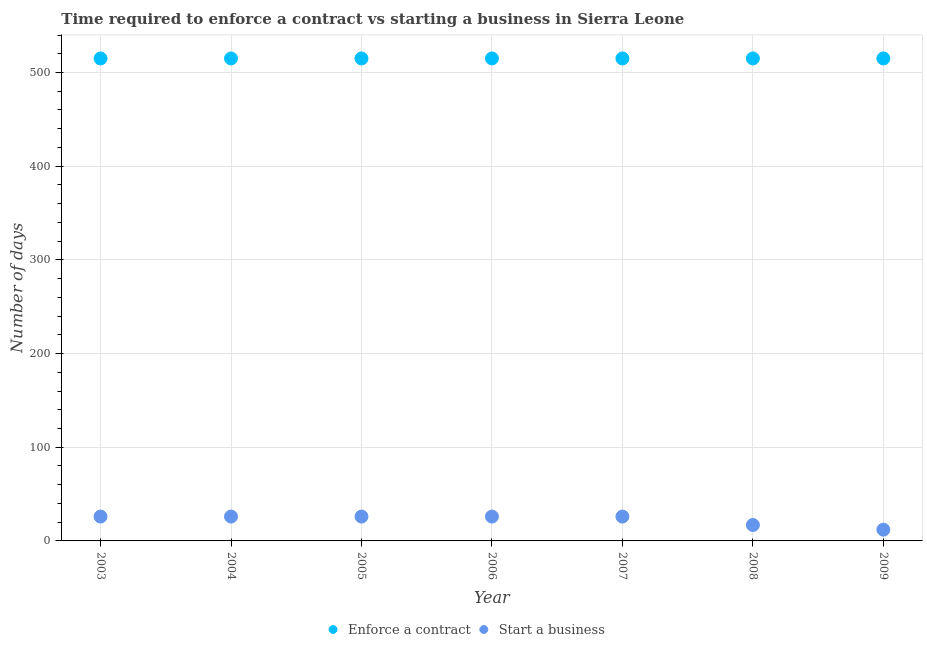How many different coloured dotlines are there?
Your answer should be very brief. 2. What is the number of days to start a business in 2005?
Your answer should be very brief. 26. Across all years, what is the maximum number of days to start a business?
Keep it short and to the point. 26. Across all years, what is the minimum number of days to start a business?
Give a very brief answer. 12. What is the total number of days to start a business in the graph?
Your answer should be very brief. 159. What is the difference between the number of days to start a business in 2008 and that in 2009?
Your response must be concise. 5. What is the difference between the number of days to enforece a contract in 2007 and the number of days to start a business in 2004?
Your answer should be compact. 489. What is the average number of days to enforece a contract per year?
Your response must be concise. 515. In the year 2008, what is the difference between the number of days to enforece a contract and number of days to start a business?
Make the answer very short. 498. What is the ratio of the number of days to enforece a contract in 2007 to that in 2009?
Make the answer very short. 1. Is the difference between the number of days to enforece a contract in 2004 and 2007 greater than the difference between the number of days to start a business in 2004 and 2007?
Keep it short and to the point. No. What is the difference between the highest and the lowest number of days to start a business?
Your response must be concise. 14. Is the sum of the number of days to start a business in 2003 and 2007 greater than the maximum number of days to enforece a contract across all years?
Your answer should be compact. No. Is the number of days to enforece a contract strictly greater than the number of days to start a business over the years?
Your answer should be very brief. Yes. Is the number of days to enforece a contract strictly less than the number of days to start a business over the years?
Keep it short and to the point. No. How many years are there in the graph?
Give a very brief answer. 7. What is the difference between two consecutive major ticks on the Y-axis?
Keep it short and to the point. 100. Where does the legend appear in the graph?
Provide a short and direct response. Bottom center. How are the legend labels stacked?
Provide a short and direct response. Horizontal. What is the title of the graph?
Your answer should be compact. Time required to enforce a contract vs starting a business in Sierra Leone. What is the label or title of the X-axis?
Ensure brevity in your answer.  Year. What is the label or title of the Y-axis?
Your answer should be very brief. Number of days. What is the Number of days in Enforce a contract in 2003?
Your answer should be very brief. 515. What is the Number of days of Enforce a contract in 2004?
Keep it short and to the point. 515. What is the Number of days in Enforce a contract in 2005?
Offer a terse response. 515. What is the Number of days of Enforce a contract in 2006?
Keep it short and to the point. 515. What is the Number of days of Start a business in 2006?
Your answer should be very brief. 26. What is the Number of days of Enforce a contract in 2007?
Offer a very short reply. 515. What is the Number of days of Enforce a contract in 2008?
Offer a terse response. 515. What is the Number of days of Start a business in 2008?
Your answer should be very brief. 17. What is the Number of days of Enforce a contract in 2009?
Keep it short and to the point. 515. What is the Number of days in Start a business in 2009?
Your answer should be compact. 12. Across all years, what is the maximum Number of days in Enforce a contract?
Offer a very short reply. 515. Across all years, what is the minimum Number of days of Enforce a contract?
Keep it short and to the point. 515. Across all years, what is the minimum Number of days of Start a business?
Your response must be concise. 12. What is the total Number of days in Enforce a contract in the graph?
Give a very brief answer. 3605. What is the total Number of days in Start a business in the graph?
Provide a short and direct response. 159. What is the difference between the Number of days in Enforce a contract in 2003 and that in 2004?
Ensure brevity in your answer.  0. What is the difference between the Number of days of Start a business in 2003 and that in 2004?
Your response must be concise. 0. What is the difference between the Number of days of Enforce a contract in 2003 and that in 2005?
Your answer should be compact. 0. What is the difference between the Number of days of Start a business in 2003 and that in 2005?
Ensure brevity in your answer.  0. What is the difference between the Number of days of Enforce a contract in 2003 and that in 2007?
Your answer should be compact. 0. What is the difference between the Number of days of Start a business in 2003 and that in 2007?
Your response must be concise. 0. What is the difference between the Number of days in Enforce a contract in 2003 and that in 2008?
Give a very brief answer. 0. What is the difference between the Number of days of Start a business in 2003 and that in 2008?
Offer a terse response. 9. What is the difference between the Number of days in Start a business in 2004 and that in 2005?
Your answer should be very brief. 0. What is the difference between the Number of days in Start a business in 2004 and that in 2007?
Give a very brief answer. 0. What is the difference between the Number of days in Enforce a contract in 2004 and that in 2008?
Give a very brief answer. 0. What is the difference between the Number of days in Enforce a contract in 2005 and that in 2006?
Provide a succinct answer. 0. What is the difference between the Number of days of Start a business in 2005 and that in 2007?
Make the answer very short. 0. What is the difference between the Number of days of Enforce a contract in 2005 and that in 2008?
Keep it short and to the point. 0. What is the difference between the Number of days of Start a business in 2005 and that in 2008?
Your answer should be very brief. 9. What is the difference between the Number of days in Start a business in 2005 and that in 2009?
Make the answer very short. 14. What is the difference between the Number of days in Enforce a contract in 2006 and that in 2007?
Your response must be concise. 0. What is the difference between the Number of days of Start a business in 2006 and that in 2008?
Ensure brevity in your answer.  9. What is the difference between the Number of days in Start a business in 2006 and that in 2009?
Keep it short and to the point. 14. What is the difference between the Number of days in Enforce a contract in 2007 and that in 2008?
Offer a very short reply. 0. What is the difference between the Number of days in Start a business in 2007 and that in 2008?
Your response must be concise. 9. What is the difference between the Number of days in Enforce a contract in 2007 and that in 2009?
Ensure brevity in your answer.  0. What is the difference between the Number of days of Start a business in 2007 and that in 2009?
Offer a terse response. 14. What is the difference between the Number of days of Enforce a contract in 2008 and that in 2009?
Your response must be concise. 0. What is the difference between the Number of days in Enforce a contract in 2003 and the Number of days in Start a business in 2004?
Offer a terse response. 489. What is the difference between the Number of days in Enforce a contract in 2003 and the Number of days in Start a business in 2005?
Make the answer very short. 489. What is the difference between the Number of days in Enforce a contract in 2003 and the Number of days in Start a business in 2006?
Ensure brevity in your answer.  489. What is the difference between the Number of days of Enforce a contract in 2003 and the Number of days of Start a business in 2007?
Provide a succinct answer. 489. What is the difference between the Number of days in Enforce a contract in 2003 and the Number of days in Start a business in 2008?
Your response must be concise. 498. What is the difference between the Number of days in Enforce a contract in 2003 and the Number of days in Start a business in 2009?
Offer a terse response. 503. What is the difference between the Number of days of Enforce a contract in 2004 and the Number of days of Start a business in 2005?
Offer a very short reply. 489. What is the difference between the Number of days in Enforce a contract in 2004 and the Number of days in Start a business in 2006?
Your response must be concise. 489. What is the difference between the Number of days of Enforce a contract in 2004 and the Number of days of Start a business in 2007?
Provide a short and direct response. 489. What is the difference between the Number of days in Enforce a contract in 2004 and the Number of days in Start a business in 2008?
Provide a succinct answer. 498. What is the difference between the Number of days in Enforce a contract in 2004 and the Number of days in Start a business in 2009?
Provide a short and direct response. 503. What is the difference between the Number of days in Enforce a contract in 2005 and the Number of days in Start a business in 2006?
Your answer should be compact. 489. What is the difference between the Number of days in Enforce a contract in 2005 and the Number of days in Start a business in 2007?
Provide a short and direct response. 489. What is the difference between the Number of days of Enforce a contract in 2005 and the Number of days of Start a business in 2008?
Provide a succinct answer. 498. What is the difference between the Number of days of Enforce a contract in 2005 and the Number of days of Start a business in 2009?
Give a very brief answer. 503. What is the difference between the Number of days in Enforce a contract in 2006 and the Number of days in Start a business in 2007?
Ensure brevity in your answer.  489. What is the difference between the Number of days in Enforce a contract in 2006 and the Number of days in Start a business in 2008?
Give a very brief answer. 498. What is the difference between the Number of days of Enforce a contract in 2006 and the Number of days of Start a business in 2009?
Your answer should be very brief. 503. What is the difference between the Number of days of Enforce a contract in 2007 and the Number of days of Start a business in 2008?
Provide a succinct answer. 498. What is the difference between the Number of days of Enforce a contract in 2007 and the Number of days of Start a business in 2009?
Give a very brief answer. 503. What is the difference between the Number of days in Enforce a contract in 2008 and the Number of days in Start a business in 2009?
Provide a succinct answer. 503. What is the average Number of days of Enforce a contract per year?
Offer a terse response. 515. What is the average Number of days of Start a business per year?
Your answer should be very brief. 22.71. In the year 2003, what is the difference between the Number of days of Enforce a contract and Number of days of Start a business?
Your answer should be very brief. 489. In the year 2004, what is the difference between the Number of days of Enforce a contract and Number of days of Start a business?
Give a very brief answer. 489. In the year 2005, what is the difference between the Number of days in Enforce a contract and Number of days in Start a business?
Your answer should be compact. 489. In the year 2006, what is the difference between the Number of days in Enforce a contract and Number of days in Start a business?
Keep it short and to the point. 489. In the year 2007, what is the difference between the Number of days in Enforce a contract and Number of days in Start a business?
Ensure brevity in your answer.  489. In the year 2008, what is the difference between the Number of days of Enforce a contract and Number of days of Start a business?
Offer a very short reply. 498. In the year 2009, what is the difference between the Number of days in Enforce a contract and Number of days in Start a business?
Your response must be concise. 503. What is the ratio of the Number of days in Enforce a contract in 2003 to that in 2005?
Provide a succinct answer. 1. What is the ratio of the Number of days of Start a business in 2003 to that in 2005?
Your answer should be very brief. 1. What is the ratio of the Number of days in Enforce a contract in 2003 to that in 2006?
Your response must be concise. 1. What is the ratio of the Number of days of Start a business in 2003 to that in 2006?
Provide a succinct answer. 1. What is the ratio of the Number of days of Enforce a contract in 2003 to that in 2008?
Your answer should be very brief. 1. What is the ratio of the Number of days of Start a business in 2003 to that in 2008?
Your answer should be compact. 1.53. What is the ratio of the Number of days in Enforce a contract in 2003 to that in 2009?
Offer a terse response. 1. What is the ratio of the Number of days in Start a business in 2003 to that in 2009?
Keep it short and to the point. 2.17. What is the ratio of the Number of days of Start a business in 2004 to that in 2005?
Keep it short and to the point. 1. What is the ratio of the Number of days of Start a business in 2004 to that in 2006?
Provide a succinct answer. 1. What is the ratio of the Number of days in Enforce a contract in 2004 to that in 2007?
Your response must be concise. 1. What is the ratio of the Number of days in Start a business in 2004 to that in 2007?
Provide a succinct answer. 1. What is the ratio of the Number of days in Start a business in 2004 to that in 2008?
Your response must be concise. 1.53. What is the ratio of the Number of days in Start a business in 2004 to that in 2009?
Ensure brevity in your answer.  2.17. What is the ratio of the Number of days in Start a business in 2005 to that in 2006?
Give a very brief answer. 1. What is the ratio of the Number of days of Start a business in 2005 to that in 2007?
Offer a very short reply. 1. What is the ratio of the Number of days in Enforce a contract in 2005 to that in 2008?
Ensure brevity in your answer.  1. What is the ratio of the Number of days in Start a business in 2005 to that in 2008?
Keep it short and to the point. 1.53. What is the ratio of the Number of days of Enforce a contract in 2005 to that in 2009?
Your response must be concise. 1. What is the ratio of the Number of days in Start a business in 2005 to that in 2009?
Provide a succinct answer. 2.17. What is the ratio of the Number of days in Enforce a contract in 2006 to that in 2007?
Ensure brevity in your answer.  1. What is the ratio of the Number of days in Enforce a contract in 2006 to that in 2008?
Ensure brevity in your answer.  1. What is the ratio of the Number of days of Start a business in 2006 to that in 2008?
Provide a short and direct response. 1.53. What is the ratio of the Number of days in Enforce a contract in 2006 to that in 2009?
Make the answer very short. 1. What is the ratio of the Number of days in Start a business in 2006 to that in 2009?
Provide a succinct answer. 2.17. What is the ratio of the Number of days of Enforce a contract in 2007 to that in 2008?
Your answer should be very brief. 1. What is the ratio of the Number of days in Start a business in 2007 to that in 2008?
Keep it short and to the point. 1.53. What is the ratio of the Number of days in Enforce a contract in 2007 to that in 2009?
Your answer should be compact. 1. What is the ratio of the Number of days in Start a business in 2007 to that in 2009?
Offer a very short reply. 2.17. What is the ratio of the Number of days of Enforce a contract in 2008 to that in 2009?
Offer a terse response. 1. What is the ratio of the Number of days in Start a business in 2008 to that in 2009?
Provide a succinct answer. 1.42. What is the difference between the highest and the second highest Number of days in Enforce a contract?
Make the answer very short. 0. What is the difference between the highest and the lowest Number of days in Enforce a contract?
Make the answer very short. 0. What is the difference between the highest and the lowest Number of days of Start a business?
Offer a very short reply. 14. 